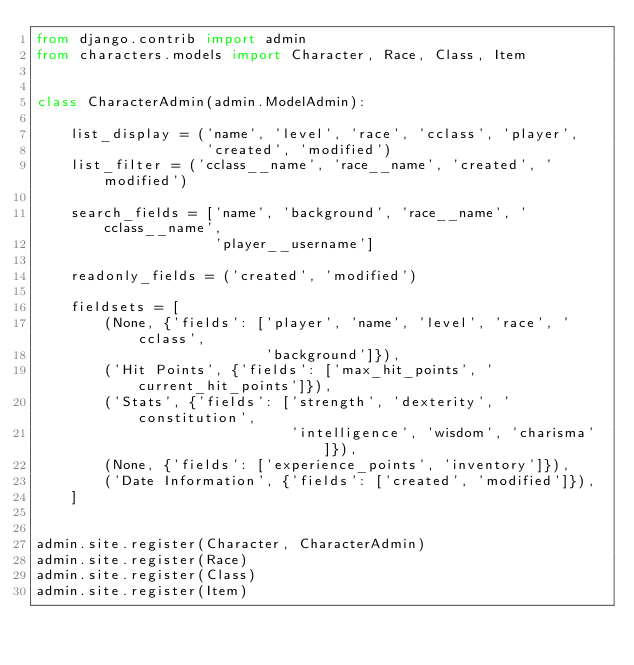<code> <loc_0><loc_0><loc_500><loc_500><_Python_>from django.contrib import admin
from characters.models import Character, Race, Class, Item


class CharacterAdmin(admin.ModelAdmin):

    list_display = ('name', 'level', 'race', 'cclass', 'player',
                    'created', 'modified')
    list_filter = ('cclass__name', 'race__name', 'created', 'modified')

    search_fields = ['name', 'background', 'race__name', 'cclass__name',
                     'player__username']

    readonly_fields = ('created', 'modified')

    fieldsets = [
        (None, {'fields': ['player', 'name', 'level', 'race', 'cclass',
                           'background']}),
        ('Hit Points', {'fields': ['max_hit_points', 'current_hit_points']}),
        ('Stats', {'fields': ['strength', 'dexterity', 'constitution',
                              'intelligence', 'wisdom', 'charisma']}),
        (None, {'fields': ['experience_points', 'inventory']}),
        ('Date Information', {'fields': ['created', 'modified']}),
    ]


admin.site.register(Character, CharacterAdmin)
admin.site.register(Race)
admin.site.register(Class)
admin.site.register(Item)
</code> 